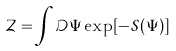Convert formula to latex. <formula><loc_0><loc_0><loc_500><loc_500>\mathcal { Z } = \int \mathcal { D } \Psi \exp [ - \mathcal { S } ( \Psi ) ]</formula> 